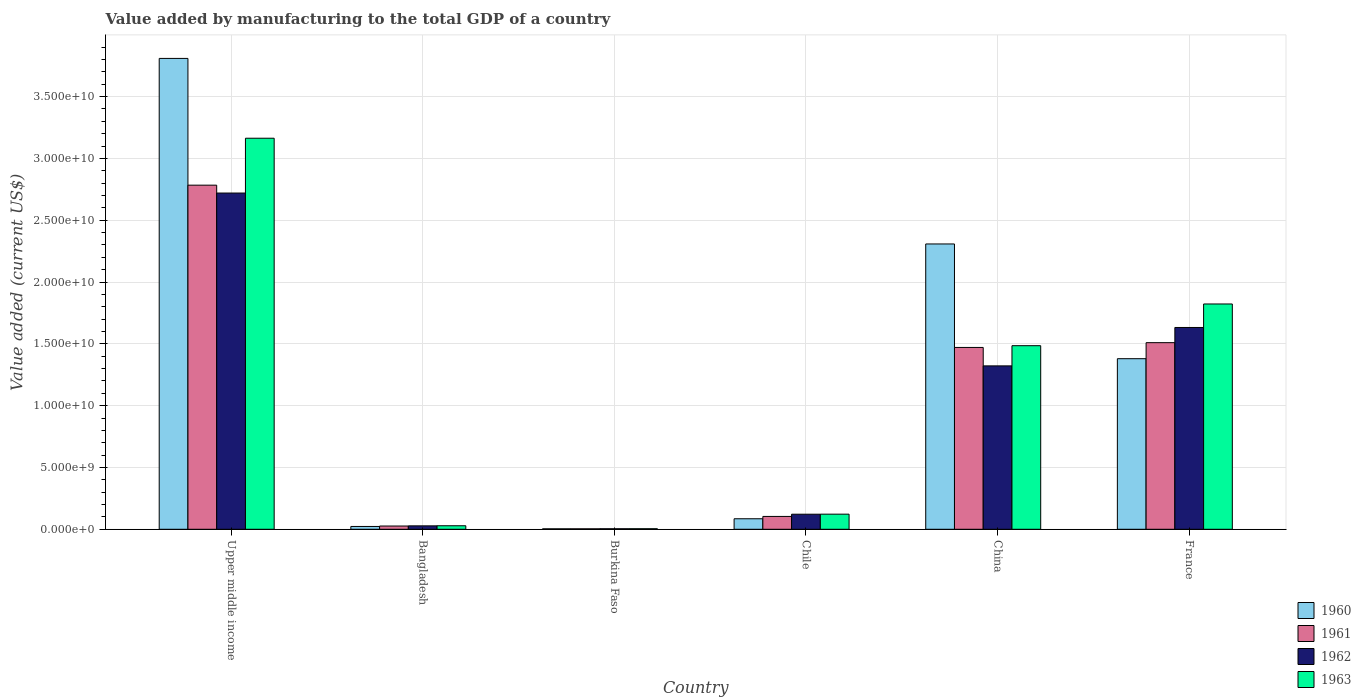How many different coloured bars are there?
Offer a terse response. 4. How many groups of bars are there?
Provide a succinct answer. 6. Are the number of bars per tick equal to the number of legend labels?
Ensure brevity in your answer.  Yes. What is the value added by manufacturing to the total GDP in 1960 in France?
Your answer should be compact. 1.38e+1. Across all countries, what is the maximum value added by manufacturing to the total GDP in 1960?
Your answer should be compact. 3.81e+1. Across all countries, what is the minimum value added by manufacturing to the total GDP in 1961?
Your answer should be compact. 3.72e+07. In which country was the value added by manufacturing to the total GDP in 1961 maximum?
Your response must be concise. Upper middle income. In which country was the value added by manufacturing to the total GDP in 1960 minimum?
Provide a succinct answer. Burkina Faso. What is the total value added by manufacturing to the total GDP in 1961 in the graph?
Provide a short and direct response. 5.90e+1. What is the difference between the value added by manufacturing to the total GDP in 1962 in Bangladesh and that in France?
Offer a terse response. -1.60e+1. What is the difference between the value added by manufacturing to the total GDP in 1960 in Chile and the value added by manufacturing to the total GDP in 1963 in Bangladesh?
Provide a succinct answer. 5.66e+08. What is the average value added by manufacturing to the total GDP in 1962 per country?
Ensure brevity in your answer.  9.71e+09. What is the difference between the value added by manufacturing to the total GDP of/in 1961 and value added by manufacturing to the total GDP of/in 1962 in Bangladesh?
Your answer should be very brief. -1.33e+07. What is the ratio of the value added by manufacturing to the total GDP in 1961 in Burkina Faso to that in Chile?
Keep it short and to the point. 0.04. Is the value added by manufacturing to the total GDP in 1963 in Chile less than that in France?
Keep it short and to the point. Yes. What is the difference between the highest and the second highest value added by manufacturing to the total GDP in 1961?
Provide a short and direct response. -1.31e+1. What is the difference between the highest and the lowest value added by manufacturing to the total GDP in 1960?
Offer a very short reply. 3.81e+1. Is it the case that in every country, the sum of the value added by manufacturing to the total GDP in 1962 and value added by manufacturing to the total GDP in 1961 is greater than the sum of value added by manufacturing to the total GDP in 1960 and value added by manufacturing to the total GDP in 1963?
Ensure brevity in your answer.  No. What does the 3rd bar from the left in Burkina Faso represents?
Your answer should be compact. 1962. Are all the bars in the graph horizontal?
Your answer should be compact. No. What is the difference between two consecutive major ticks on the Y-axis?
Keep it short and to the point. 5.00e+09. Does the graph contain grids?
Ensure brevity in your answer.  Yes. What is the title of the graph?
Offer a very short reply. Value added by manufacturing to the total GDP of a country. What is the label or title of the X-axis?
Keep it short and to the point. Country. What is the label or title of the Y-axis?
Your answer should be compact. Value added (current US$). What is the Value added (current US$) in 1960 in Upper middle income?
Keep it short and to the point. 3.81e+1. What is the Value added (current US$) in 1961 in Upper middle income?
Your answer should be compact. 2.78e+1. What is the Value added (current US$) of 1962 in Upper middle income?
Make the answer very short. 2.72e+1. What is the Value added (current US$) of 1963 in Upper middle income?
Offer a terse response. 3.16e+1. What is the Value added (current US$) in 1960 in Bangladesh?
Offer a very short reply. 2.27e+08. What is the Value added (current US$) in 1961 in Bangladesh?
Your answer should be very brief. 2.64e+08. What is the Value added (current US$) of 1962 in Bangladesh?
Your response must be concise. 2.77e+08. What is the Value added (current US$) of 1963 in Bangladesh?
Give a very brief answer. 2.85e+08. What is the Value added (current US$) of 1960 in Burkina Faso?
Keep it short and to the point. 3.72e+07. What is the Value added (current US$) of 1961 in Burkina Faso?
Give a very brief answer. 3.72e+07. What is the Value added (current US$) of 1962 in Burkina Faso?
Provide a succinct answer. 4.22e+07. What is the Value added (current US$) in 1963 in Burkina Faso?
Your answer should be compact. 4.39e+07. What is the Value added (current US$) of 1960 in Chile?
Give a very brief answer. 8.51e+08. What is the Value added (current US$) in 1961 in Chile?
Provide a succinct answer. 1.04e+09. What is the Value added (current US$) in 1962 in Chile?
Give a very brief answer. 1.22e+09. What is the Value added (current US$) in 1963 in Chile?
Provide a short and direct response. 1.22e+09. What is the Value added (current US$) of 1960 in China?
Provide a short and direct response. 2.31e+1. What is the Value added (current US$) of 1961 in China?
Provide a short and direct response. 1.47e+1. What is the Value added (current US$) of 1962 in China?
Ensure brevity in your answer.  1.32e+1. What is the Value added (current US$) in 1963 in China?
Your response must be concise. 1.49e+1. What is the Value added (current US$) in 1960 in France?
Keep it short and to the point. 1.38e+1. What is the Value added (current US$) of 1961 in France?
Provide a succinct answer. 1.51e+1. What is the Value added (current US$) of 1962 in France?
Ensure brevity in your answer.  1.63e+1. What is the Value added (current US$) of 1963 in France?
Offer a terse response. 1.82e+1. Across all countries, what is the maximum Value added (current US$) in 1960?
Keep it short and to the point. 3.81e+1. Across all countries, what is the maximum Value added (current US$) in 1961?
Ensure brevity in your answer.  2.78e+1. Across all countries, what is the maximum Value added (current US$) of 1962?
Offer a very short reply. 2.72e+1. Across all countries, what is the maximum Value added (current US$) of 1963?
Offer a terse response. 3.16e+1. Across all countries, what is the minimum Value added (current US$) of 1960?
Keep it short and to the point. 3.72e+07. Across all countries, what is the minimum Value added (current US$) of 1961?
Your answer should be very brief. 3.72e+07. Across all countries, what is the minimum Value added (current US$) of 1962?
Ensure brevity in your answer.  4.22e+07. Across all countries, what is the minimum Value added (current US$) in 1963?
Your answer should be compact. 4.39e+07. What is the total Value added (current US$) in 1960 in the graph?
Give a very brief answer. 7.61e+1. What is the total Value added (current US$) in 1961 in the graph?
Your answer should be very brief. 5.90e+1. What is the total Value added (current US$) of 1962 in the graph?
Give a very brief answer. 5.83e+1. What is the total Value added (current US$) of 1963 in the graph?
Provide a succinct answer. 6.63e+1. What is the difference between the Value added (current US$) of 1960 in Upper middle income and that in Bangladesh?
Offer a terse response. 3.79e+1. What is the difference between the Value added (current US$) of 1961 in Upper middle income and that in Bangladesh?
Offer a very short reply. 2.76e+1. What is the difference between the Value added (current US$) of 1962 in Upper middle income and that in Bangladesh?
Ensure brevity in your answer.  2.69e+1. What is the difference between the Value added (current US$) in 1963 in Upper middle income and that in Bangladesh?
Give a very brief answer. 3.13e+1. What is the difference between the Value added (current US$) in 1960 in Upper middle income and that in Burkina Faso?
Offer a very short reply. 3.81e+1. What is the difference between the Value added (current US$) of 1961 in Upper middle income and that in Burkina Faso?
Provide a short and direct response. 2.78e+1. What is the difference between the Value added (current US$) in 1962 in Upper middle income and that in Burkina Faso?
Ensure brevity in your answer.  2.72e+1. What is the difference between the Value added (current US$) in 1963 in Upper middle income and that in Burkina Faso?
Offer a terse response. 3.16e+1. What is the difference between the Value added (current US$) of 1960 in Upper middle income and that in Chile?
Your response must be concise. 3.72e+1. What is the difference between the Value added (current US$) in 1961 in Upper middle income and that in Chile?
Your answer should be very brief. 2.68e+1. What is the difference between the Value added (current US$) in 1962 in Upper middle income and that in Chile?
Provide a short and direct response. 2.60e+1. What is the difference between the Value added (current US$) in 1963 in Upper middle income and that in Chile?
Provide a short and direct response. 3.04e+1. What is the difference between the Value added (current US$) of 1960 in Upper middle income and that in China?
Offer a very short reply. 1.50e+1. What is the difference between the Value added (current US$) in 1961 in Upper middle income and that in China?
Make the answer very short. 1.31e+1. What is the difference between the Value added (current US$) of 1962 in Upper middle income and that in China?
Your response must be concise. 1.40e+1. What is the difference between the Value added (current US$) in 1963 in Upper middle income and that in China?
Your answer should be compact. 1.68e+1. What is the difference between the Value added (current US$) of 1960 in Upper middle income and that in France?
Provide a succinct answer. 2.43e+1. What is the difference between the Value added (current US$) in 1961 in Upper middle income and that in France?
Provide a succinct answer. 1.27e+1. What is the difference between the Value added (current US$) in 1962 in Upper middle income and that in France?
Give a very brief answer. 1.09e+1. What is the difference between the Value added (current US$) of 1963 in Upper middle income and that in France?
Give a very brief answer. 1.34e+1. What is the difference between the Value added (current US$) in 1960 in Bangladesh and that in Burkina Faso?
Your answer should be very brief. 1.90e+08. What is the difference between the Value added (current US$) in 1961 in Bangladesh and that in Burkina Faso?
Keep it short and to the point. 2.26e+08. What is the difference between the Value added (current US$) in 1962 in Bangladesh and that in Burkina Faso?
Ensure brevity in your answer.  2.35e+08. What is the difference between the Value added (current US$) of 1963 in Bangladesh and that in Burkina Faso?
Offer a terse response. 2.41e+08. What is the difference between the Value added (current US$) of 1960 in Bangladesh and that in Chile?
Offer a terse response. -6.24e+08. What is the difference between the Value added (current US$) in 1961 in Bangladesh and that in Chile?
Provide a short and direct response. -7.75e+08. What is the difference between the Value added (current US$) in 1962 in Bangladesh and that in Chile?
Provide a succinct answer. -9.41e+08. What is the difference between the Value added (current US$) of 1963 in Bangladesh and that in Chile?
Offer a very short reply. -9.38e+08. What is the difference between the Value added (current US$) of 1960 in Bangladesh and that in China?
Provide a succinct answer. -2.29e+1. What is the difference between the Value added (current US$) of 1961 in Bangladesh and that in China?
Your answer should be compact. -1.44e+1. What is the difference between the Value added (current US$) of 1962 in Bangladesh and that in China?
Offer a very short reply. -1.29e+1. What is the difference between the Value added (current US$) in 1963 in Bangladesh and that in China?
Keep it short and to the point. -1.46e+1. What is the difference between the Value added (current US$) of 1960 in Bangladesh and that in France?
Your answer should be very brief. -1.36e+1. What is the difference between the Value added (current US$) in 1961 in Bangladesh and that in France?
Offer a very short reply. -1.48e+1. What is the difference between the Value added (current US$) in 1962 in Bangladesh and that in France?
Ensure brevity in your answer.  -1.60e+1. What is the difference between the Value added (current US$) in 1963 in Bangladesh and that in France?
Offer a very short reply. -1.79e+1. What is the difference between the Value added (current US$) of 1960 in Burkina Faso and that in Chile?
Provide a short and direct response. -8.13e+08. What is the difference between the Value added (current US$) in 1961 in Burkina Faso and that in Chile?
Your response must be concise. -1.00e+09. What is the difference between the Value added (current US$) of 1962 in Burkina Faso and that in Chile?
Ensure brevity in your answer.  -1.18e+09. What is the difference between the Value added (current US$) of 1963 in Burkina Faso and that in Chile?
Your answer should be very brief. -1.18e+09. What is the difference between the Value added (current US$) in 1960 in Burkina Faso and that in China?
Your response must be concise. -2.30e+1. What is the difference between the Value added (current US$) of 1961 in Burkina Faso and that in China?
Provide a short and direct response. -1.47e+1. What is the difference between the Value added (current US$) of 1962 in Burkina Faso and that in China?
Keep it short and to the point. -1.32e+1. What is the difference between the Value added (current US$) of 1963 in Burkina Faso and that in China?
Your response must be concise. -1.48e+1. What is the difference between the Value added (current US$) in 1960 in Burkina Faso and that in France?
Offer a very short reply. -1.38e+1. What is the difference between the Value added (current US$) of 1961 in Burkina Faso and that in France?
Your answer should be compact. -1.51e+1. What is the difference between the Value added (current US$) in 1962 in Burkina Faso and that in France?
Provide a short and direct response. -1.63e+1. What is the difference between the Value added (current US$) of 1963 in Burkina Faso and that in France?
Your answer should be compact. -1.82e+1. What is the difference between the Value added (current US$) of 1960 in Chile and that in China?
Provide a succinct answer. -2.22e+1. What is the difference between the Value added (current US$) in 1961 in Chile and that in China?
Offer a terse response. -1.37e+1. What is the difference between the Value added (current US$) in 1962 in Chile and that in China?
Offer a very short reply. -1.20e+1. What is the difference between the Value added (current US$) in 1963 in Chile and that in China?
Make the answer very short. -1.36e+1. What is the difference between the Value added (current US$) in 1960 in Chile and that in France?
Give a very brief answer. -1.29e+1. What is the difference between the Value added (current US$) of 1961 in Chile and that in France?
Ensure brevity in your answer.  -1.41e+1. What is the difference between the Value added (current US$) of 1962 in Chile and that in France?
Keep it short and to the point. -1.51e+1. What is the difference between the Value added (current US$) of 1963 in Chile and that in France?
Provide a succinct answer. -1.70e+1. What is the difference between the Value added (current US$) of 1960 in China and that in France?
Give a very brief answer. 9.28e+09. What is the difference between the Value added (current US$) in 1961 in China and that in France?
Offer a very short reply. -3.87e+08. What is the difference between the Value added (current US$) in 1962 in China and that in France?
Your response must be concise. -3.11e+09. What is the difference between the Value added (current US$) of 1963 in China and that in France?
Keep it short and to the point. -3.37e+09. What is the difference between the Value added (current US$) in 1960 in Upper middle income and the Value added (current US$) in 1961 in Bangladesh?
Offer a terse response. 3.78e+1. What is the difference between the Value added (current US$) of 1960 in Upper middle income and the Value added (current US$) of 1962 in Bangladesh?
Your answer should be very brief. 3.78e+1. What is the difference between the Value added (current US$) of 1960 in Upper middle income and the Value added (current US$) of 1963 in Bangladesh?
Your answer should be compact. 3.78e+1. What is the difference between the Value added (current US$) of 1961 in Upper middle income and the Value added (current US$) of 1962 in Bangladesh?
Your response must be concise. 2.76e+1. What is the difference between the Value added (current US$) of 1961 in Upper middle income and the Value added (current US$) of 1963 in Bangladesh?
Your answer should be very brief. 2.76e+1. What is the difference between the Value added (current US$) in 1962 in Upper middle income and the Value added (current US$) in 1963 in Bangladesh?
Provide a succinct answer. 2.69e+1. What is the difference between the Value added (current US$) in 1960 in Upper middle income and the Value added (current US$) in 1961 in Burkina Faso?
Offer a very short reply. 3.81e+1. What is the difference between the Value added (current US$) in 1960 in Upper middle income and the Value added (current US$) in 1962 in Burkina Faso?
Ensure brevity in your answer.  3.80e+1. What is the difference between the Value added (current US$) of 1960 in Upper middle income and the Value added (current US$) of 1963 in Burkina Faso?
Keep it short and to the point. 3.80e+1. What is the difference between the Value added (current US$) in 1961 in Upper middle income and the Value added (current US$) in 1962 in Burkina Faso?
Offer a terse response. 2.78e+1. What is the difference between the Value added (current US$) in 1961 in Upper middle income and the Value added (current US$) in 1963 in Burkina Faso?
Give a very brief answer. 2.78e+1. What is the difference between the Value added (current US$) in 1962 in Upper middle income and the Value added (current US$) in 1963 in Burkina Faso?
Your response must be concise. 2.72e+1. What is the difference between the Value added (current US$) of 1960 in Upper middle income and the Value added (current US$) of 1961 in Chile?
Give a very brief answer. 3.71e+1. What is the difference between the Value added (current US$) in 1960 in Upper middle income and the Value added (current US$) in 1962 in Chile?
Provide a succinct answer. 3.69e+1. What is the difference between the Value added (current US$) of 1960 in Upper middle income and the Value added (current US$) of 1963 in Chile?
Make the answer very short. 3.69e+1. What is the difference between the Value added (current US$) of 1961 in Upper middle income and the Value added (current US$) of 1962 in Chile?
Provide a succinct answer. 2.66e+1. What is the difference between the Value added (current US$) of 1961 in Upper middle income and the Value added (current US$) of 1963 in Chile?
Offer a terse response. 2.66e+1. What is the difference between the Value added (current US$) of 1962 in Upper middle income and the Value added (current US$) of 1963 in Chile?
Ensure brevity in your answer.  2.60e+1. What is the difference between the Value added (current US$) of 1960 in Upper middle income and the Value added (current US$) of 1961 in China?
Offer a terse response. 2.34e+1. What is the difference between the Value added (current US$) of 1960 in Upper middle income and the Value added (current US$) of 1962 in China?
Provide a succinct answer. 2.49e+1. What is the difference between the Value added (current US$) in 1960 in Upper middle income and the Value added (current US$) in 1963 in China?
Provide a short and direct response. 2.32e+1. What is the difference between the Value added (current US$) in 1961 in Upper middle income and the Value added (current US$) in 1962 in China?
Make the answer very short. 1.46e+1. What is the difference between the Value added (current US$) in 1961 in Upper middle income and the Value added (current US$) in 1963 in China?
Your answer should be compact. 1.30e+1. What is the difference between the Value added (current US$) in 1962 in Upper middle income and the Value added (current US$) in 1963 in China?
Give a very brief answer. 1.23e+1. What is the difference between the Value added (current US$) of 1960 in Upper middle income and the Value added (current US$) of 1961 in France?
Your answer should be very brief. 2.30e+1. What is the difference between the Value added (current US$) in 1960 in Upper middle income and the Value added (current US$) in 1962 in France?
Give a very brief answer. 2.18e+1. What is the difference between the Value added (current US$) in 1960 in Upper middle income and the Value added (current US$) in 1963 in France?
Your response must be concise. 1.99e+1. What is the difference between the Value added (current US$) in 1961 in Upper middle income and the Value added (current US$) in 1962 in France?
Your answer should be very brief. 1.15e+1. What is the difference between the Value added (current US$) of 1961 in Upper middle income and the Value added (current US$) of 1963 in France?
Ensure brevity in your answer.  9.61e+09. What is the difference between the Value added (current US$) in 1962 in Upper middle income and the Value added (current US$) in 1963 in France?
Make the answer very short. 8.97e+09. What is the difference between the Value added (current US$) in 1960 in Bangladesh and the Value added (current US$) in 1961 in Burkina Faso?
Your answer should be compact. 1.90e+08. What is the difference between the Value added (current US$) in 1960 in Bangladesh and the Value added (current US$) in 1962 in Burkina Faso?
Keep it short and to the point. 1.85e+08. What is the difference between the Value added (current US$) in 1960 in Bangladesh and the Value added (current US$) in 1963 in Burkina Faso?
Make the answer very short. 1.83e+08. What is the difference between the Value added (current US$) of 1961 in Bangladesh and the Value added (current US$) of 1962 in Burkina Faso?
Give a very brief answer. 2.21e+08. What is the difference between the Value added (current US$) of 1961 in Bangladesh and the Value added (current US$) of 1963 in Burkina Faso?
Provide a short and direct response. 2.20e+08. What is the difference between the Value added (current US$) of 1962 in Bangladesh and the Value added (current US$) of 1963 in Burkina Faso?
Keep it short and to the point. 2.33e+08. What is the difference between the Value added (current US$) of 1960 in Bangladesh and the Value added (current US$) of 1961 in Chile?
Ensure brevity in your answer.  -8.12e+08. What is the difference between the Value added (current US$) in 1960 in Bangladesh and the Value added (current US$) in 1962 in Chile?
Your response must be concise. -9.91e+08. What is the difference between the Value added (current US$) of 1960 in Bangladesh and the Value added (current US$) of 1963 in Chile?
Make the answer very short. -9.96e+08. What is the difference between the Value added (current US$) of 1961 in Bangladesh and the Value added (current US$) of 1962 in Chile?
Provide a short and direct response. -9.55e+08. What is the difference between the Value added (current US$) in 1961 in Bangladesh and the Value added (current US$) in 1963 in Chile?
Keep it short and to the point. -9.59e+08. What is the difference between the Value added (current US$) in 1962 in Bangladesh and the Value added (current US$) in 1963 in Chile?
Your response must be concise. -9.46e+08. What is the difference between the Value added (current US$) of 1960 in Bangladesh and the Value added (current US$) of 1961 in China?
Give a very brief answer. -1.45e+1. What is the difference between the Value added (current US$) in 1960 in Bangladesh and the Value added (current US$) in 1962 in China?
Provide a short and direct response. -1.30e+1. What is the difference between the Value added (current US$) in 1960 in Bangladesh and the Value added (current US$) in 1963 in China?
Your answer should be compact. -1.46e+1. What is the difference between the Value added (current US$) in 1961 in Bangladesh and the Value added (current US$) in 1962 in China?
Keep it short and to the point. -1.30e+1. What is the difference between the Value added (current US$) in 1961 in Bangladesh and the Value added (current US$) in 1963 in China?
Your answer should be compact. -1.46e+1. What is the difference between the Value added (current US$) of 1962 in Bangladesh and the Value added (current US$) of 1963 in China?
Offer a very short reply. -1.46e+1. What is the difference between the Value added (current US$) of 1960 in Bangladesh and the Value added (current US$) of 1961 in France?
Offer a very short reply. -1.49e+1. What is the difference between the Value added (current US$) in 1960 in Bangladesh and the Value added (current US$) in 1962 in France?
Your answer should be very brief. -1.61e+1. What is the difference between the Value added (current US$) of 1960 in Bangladesh and the Value added (current US$) of 1963 in France?
Ensure brevity in your answer.  -1.80e+1. What is the difference between the Value added (current US$) of 1961 in Bangladesh and the Value added (current US$) of 1962 in France?
Your answer should be very brief. -1.61e+1. What is the difference between the Value added (current US$) of 1961 in Bangladesh and the Value added (current US$) of 1963 in France?
Ensure brevity in your answer.  -1.80e+1. What is the difference between the Value added (current US$) in 1962 in Bangladesh and the Value added (current US$) in 1963 in France?
Ensure brevity in your answer.  -1.79e+1. What is the difference between the Value added (current US$) of 1960 in Burkina Faso and the Value added (current US$) of 1961 in Chile?
Give a very brief answer. -1.00e+09. What is the difference between the Value added (current US$) of 1960 in Burkina Faso and the Value added (current US$) of 1962 in Chile?
Provide a short and direct response. -1.18e+09. What is the difference between the Value added (current US$) of 1960 in Burkina Faso and the Value added (current US$) of 1963 in Chile?
Offer a terse response. -1.19e+09. What is the difference between the Value added (current US$) of 1961 in Burkina Faso and the Value added (current US$) of 1962 in Chile?
Offer a very short reply. -1.18e+09. What is the difference between the Value added (current US$) of 1961 in Burkina Faso and the Value added (current US$) of 1963 in Chile?
Ensure brevity in your answer.  -1.19e+09. What is the difference between the Value added (current US$) of 1962 in Burkina Faso and the Value added (current US$) of 1963 in Chile?
Provide a succinct answer. -1.18e+09. What is the difference between the Value added (current US$) in 1960 in Burkina Faso and the Value added (current US$) in 1961 in China?
Give a very brief answer. -1.47e+1. What is the difference between the Value added (current US$) of 1960 in Burkina Faso and the Value added (current US$) of 1962 in China?
Give a very brief answer. -1.32e+1. What is the difference between the Value added (current US$) in 1960 in Burkina Faso and the Value added (current US$) in 1963 in China?
Offer a very short reply. -1.48e+1. What is the difference between the Value added (current US$) in 1961 in Burkina Faso and the Value added (current US$) in 1962 in China?
Make the answer very short. -1.32e+1. What is the difference between the Value added (current US$) in 1961 in Burkina Faso and the Value added (current US$) in 1963 in China?
Your response must be concise. -1.48e+1. What is the difference between the Value added (current US$) of 1962 in Burkina Faso and the Value added (current US$) of 1963 in China?
Keep it short and to the point. -1.48e+1. What is the difference between the Value added (current US$) in 1960 in Burkina Faso and the Value added (current US$) in 1961 in France?
Offer a very short reply. -1.51e+1. What is the difference between the Value added (current US$) in 1960 in Burkina Faso and the Value added (current US$) in 1962 in France?
Your response must be concise. -1.63e+1. What is the difference between the Value added (current US$) in 1960 in Burkina Faso and the Value added (current US$) in 1963 in France?
Make the answer very short. -1.82e+1. What is the difference between the Value added (current US$) of 1961 in Burkina Faso and the Value added (current US$) of 1962 in France?
Keep it short and to the point. -1.63e+1. What is the difference between the Value added (current US$) of 1961 in Burkina Faso and the Value added (current US$) of 1963 in France?
Make the answer very short. -1.82e+1. What is the difference between the Value added (current US$) of 1962 in Burkina Faso and the Value added (current US$) of 1963 in France?
Make the answer very short. -1.82e+1. What is the difference between the Value added (current US$) in 1960 in Chile and the Value added (current US$) in 1961 in China?
Provide a succinct answer. -1.39e+1. What is the difference between the Value added (current US$) in 1960 in Chile and the Value added (current US$) in 1962 in China?
Keep it short and to the point. -1.24e+1. What is the difference between the Value added (current US$) in 1960 in Chile and the Value added (current US$) in 1963 in China?
Keep it short and to the point. -1.40e+1. What is the difference between the Value added (current US$) of 1961 in Chile and the Value added (current US$) of 1962 in China?
Your answer should be very brief. -1.22e+1. What is the difference between the Value added (current US$) of 1961 in Chile and the Value added (current US$) of 1963 in China?
Your response must be concise. -1.38e+1. What is the difference between the Value added (current US$) of 1962 in Chile and the Value added (current US$) of 1963 in China?
Your response must be concise. -1.36e+1. What is the difference between the Value added (current US$) of 1960 in Chile and the Value added (current US$) of 1961 in France?
Make the answer very short. -1.42e+1. What is the difference between the Value added (current US$) of 1960 in Chile and the Value added (current US$) of 1962 in France?
Provide a succinct answer. -1.55e+1. What is the difference between the Value added (current US$) of 1960 in Chile and the Value added (current US$) of 1963 in France?
Keep it short and to the point. -1.74e+1. What is the difference between the Value added (current US$) of 1961 in Chile and the Value added (current US$) of 1962 in France?
Your answer should be compact. -1.53e+1. What is the difference between the Value added (current US$) in 1961 in Chile and the Value added (current US$) in 1963 in France?
Your answer should be compact. -1.72e+1. What is the difference between the Value added (current US$) of 1962 in Chile and the Value added (current US$) of 1963 in France?
Your response must be concise. -1.70e+1. What is the difference between the Value added (current US$) in 1960 in China and the Value added (current US$) in 1961 in France?
Provide a succinct answer. 7.98e+09. What is the difference between the Value added (current US$) of 1960 in China and the Value added (current US$) of 1962 in France?
Your answer should be very brief. 6.76e+09. What is the difference between the Value added (current US$) in 1960 in China and the Value added (current US$) in 1963 in France?
Offer a terse response. 4.86e+09. What is the difference between the Value added (current US$) of 1961 in China and the Value added (current US$) of 1962 in France?
Provide a short and direct response. -1.61e+09. What is the difference between the Value added (current US$) in 1961 in China and the Value added (current US$) in 1963 in France?
Your answer should be compact. -3.52e+09. What is the difference between the Value added (current US$) of 1962 in China and the Value added (current US$) of 1963 in France?
Provide a short and direct response. -5.01e+09. What is the average Value added (current US$) of 1960 per country?
Your response must be concise. 1.27e+1. What is the average Value added (current US$) of 1961 per country?
Give a very brief answer. 9.83e+09. What is the average Value added (current US$) of 1962 per country?
Give a very brief answer. 9.71e+09. What is the average Value added (current US$) of 1963 per country?
Your response must be concise. 1.10e+1. What is the difference between the Value added (current US$) of 1960 and Value added (current US$) of 1961 in Upper middle income?
Your response must be concise. 1.03e+1. What is the difference between the Value added (current US$) in 1960 and Value added (current US$) in 1962 in Upper middle income?
Offer a terse response. 1.09e+1. What is the difference between the Value added (current US$) in 1960 and Value added (current US$) in 1963 in Upper middle income?
Your response must be concise. 6.46e+09. What is the difference between the Value added (current US$) of 1961 and Value added (current US$) of 1962 in Upper middle income?
Make the answer very short. 6.38e+08. What is the difference between the Value added (current US$) of 1961 and Value added (current US$) of 1963 in Upper middle income?
Your answer should be compact. -3.80e+09. What is the difference between the Value added (current US$) of 1962 and Value added (current US$) of 1963 in Upper middle income?
Your answer should be compact. -4.43e+09. What is the difference between the Value added (current US$) of 1960 and Value added (current US$) of 1961 in Bangladesh?
Your answer should be very brief. -3.66e+07. What is the difference between the Value added (current US$) in 1960 and Value added (current US$) in 1962 in Bangladesh?
Make the answer very short. -4.99e+07. What is the difference between the Value added (current US$) of 1960 and Value added (current US$) of 1963 in Bangladesh?
Your answer should be compact. -5.81e+07. What is the difference between the Value added (current US$) of 1961 and Value added (current US$) of 1962 in Bangladesh?
Offer a terse response. -1.33e+07. What is the difference between the Value added (current US$) in 1961 and Value added (current US$) in 1963 in Bangladesh?
Offer a very short reply. -2.15e+07. What is the difference between the Value added (current US$) of 1962 and Value added (current US$) of 1963 in Bangladesh?
Provide a succinct answer. -8.22e+06. What is the difference between the Value added (current US$) in 1960 and Value added (current US$) in 1961 in Burkina Faso?
Offer a very short reply. 9866.11. What is the difference between the Value added (current US$) in 1960 and Value added (current US$) in 1962 in Burkina Faso?
Provide a short and direct response. -5.00e+06. What is the difference between the Value added (current US$) in 1960 and Value added (current US$) in 1963 in Burkina Faso?
Provide a succinct answer. -6.65e+06. What is the difference between the Value added (current US$) of 1961 and Value added (current US$) of 1962 in Burkina Faso?
Make the answer very short. -5.01e+06. What is the difference between the Value added (current US$) in 1961 and Value added (current US$) in 1963 in Burkina Faso?
Offer a terse response. -6.66e+06. What is the difference between the Value added (current US$) of 1962 and Value added (current US$) of 1963 in Burkina Faso?
Offer a very short reply. -1.65e+06. What is the difference between the Value added (current US$) in 1960 and Value added (current US$) in 1961 in Chile?
Keep it short and to the point. -1.88e+08. What is the difference between the Value added (current US$) in 1960 and Value added (current US$) in 1962 in Chile?
Provide a succinct answer. -3.68e+08. What is the difference between the Value added (current US$) in 1960 and Value added (current US$) in 1963 in Chile?
Give a very brief answer. -3.72e+08. What is the difference between the Value added (current US$) of 1961 and Value added (current US$) of 1962 in Chile?
Offer a very short reply. -1.80e+08. What is the difference between the Value added (current US$) of 1961 and Value added (current US$) of 1963 in Chile?
Keep it short and to the point. -1.84e+08. What is the difference between the Value added (current US$) in 1962 and Value added (current US$) in 1963 in Chile?
Keep it short and to the point. -4.28e+06. What is the difference between the Value added (current US$) in 1960 and Value added (current US$) in 1961 in China?
Your answer should be very brief. 8.37e+09. What is the difference between the Value added (current US$) in 1960 and Value added (current US$) in 1962 in China?
Your answer should be very brief. 9.86e+09. What is the difference between the Value added (current US$) of 1960 and Value added (current US$) of 1963 in China?
Your response must be concise. 8.23e+09. What is the difference between the Value added (current US$) in 1961 and Value added (current US$) in 1962 in China?
Make the answer very short. 1.49e+09. What is the difference between the Value added (current US$) of 1961 and Value added (current US$) of 1963 in China?
Make the answer very short. -1.42e+08. What is the difference between the Value added (current US$) of 1962 and Value added (current US$) of 1963 in China?
Offer a very short reply. -1.63e+09. What is the difference between the Value added (current US$) of 1960 and Value added (current US$) of 1961 in France?
Offer a terse response. -1.30e+09. What is the difference between the Value added (current US$) of 1960 and Value added (current US$) of 1962 in France?
Provide a succinct answer. -2.52e+09. What is the difference between the Value added (current US$) in 1960 and Value added (current US$) in 1963 in France?
Ensure brevity in your answer.  -4.43e+09. What is the difference between the Value added (current US$) of 1961 and Value added (current US$) of 1962 in France?
Offer a very short reply. -1.23e+09. What is the difference between the Value added (current US$) of 1961 and Value added (current US$) of 1963 in France?
Your answer should be very brief. -3.13e+09. What is the difference between the Value added (current US$) of 1962 and Value added (current US$) of 1963 in France?
Offer a terse response. -1.90e+09. What is the ratio of the Value added (current US$) of 1960 in Upper middle income to that in Bangladesh?
Provide a short and direct response. 167.8. What is the ratio of the Value added (current US$) in 1961 in Upper middle income to that in Bangladesh?
Give a very brief answer. 105.62. What is the ratio of the Value added (current US$) in 1962 in Upper middle income to that in Bangladesh?
Give a very brief answer. 98.24. What is the ratio of the Value added (current US$) of 1963 in Upper middle income to that in Bangladesh?
Ensure brevity in your answer.  110.96. What is the ratio of the Value added (current US$) in 1960 in Upper middle income to that in Burkina Faso?
Ensure brevity in your answer.  1023.17. What is the ratio of the Value added (current US$) in 1961 in Upper middle income to that in Burkina Faso?
Give a very brief answer. 747.95. What is the ratio of the Value added (current US$) of 1962 in Upper middle income to that in Burkina Faso?
Provide a succinct answer. 644.09. What is the ratio of the Value added (current US$) in 1963 in Upper middle income to that in Burkina Faso?
Provide a succinct answer. 720.87. What is the ratio of the Value added (current US$) of 1960 in Upper middle income to that in Chile?
Offer a terse response. 44.77. What is the ratio of the Value added (current US$) in 1961 in Upper middle income to that in Chile?
Offer a very short reply. 26.8. What is the ratio of the Value added (current US$) of 1962 in Upper middle income to that in Chile?
Your response must be concise. 22.32. What is the ratio of the Value added (current US$) of 1963 in Upper middle income to that in Chile?
Make the answer very short. 25.87. What is the ratio of the Value added (current US$) in 1960 in Upper middle income to that in China?
Ensure brevity in your answer.  1.65. What is the ratio of the Value added (current US$) of 1961 in Upper middle income to that in China?
Provide a succinct answer. 1.89. What is the ratio of the Value added (current US$) in 1962 in Upper middle income to that in China?
Make the answer very short. 2.06. What is the ratio of the Value added (current US$) in 1963 in Upper middle income to that in China?
Your answer should be compact. 2.13. What is the ratio of the Value added (current US$) of 1960 in Upper middle income to that in France?
Provide a succinct answer. 2.76. What is the ratio of the Value added (current US$) in 1961 in Upper middle income to that in France?
Your answer should be very brief. 1.84. What is the ratio of the Value added (current US$) in 1962 in Upper middle income to that in France?
Make the answer very short. 1.67. What is the ratio of the Value added (current US$) of 1963 in Upper middle income to that in France?
Provide a succinct answer. 1.74. What is the ratio of the Value added (current US$) in 1960 in Bangladesh to that in Burkina Faso?
Give a very brief answer. 6.1. What is the ratio of the Value added (current US$) in 1961 in Bangladesh to that in Burkina Faso?
Keep it short and to the point. 7.08. What is the ratio of the Value added (current US$) of 1962 in Bangladesh to that in Burkina Faso?
Ensure brevity in your answer.  6.56. What is the ratio of the Value added (current US$) of 1963 in Bangladesh to that in Burkina Faso?
Ensure brevity in your answer.  6.5. What is the ratio of the Value added (current US$) of 1960 in Bangladesh to that in Chile?
Your answer should be compact. 0.27. What is the ratio of the Value added (current US$) of 1961 in Bangladesh to that in Chile?
Offer a terse response. 0.25. What is the ratio of the Value added (current US$) of 1962 in Bangladesh to that in Chile?
Your answer should be very brief. 0.23. What is the ratio of the Value added (current US$) in 1963 in Bangladesh to that in Chile?
Ensure brevity in your answer.  0.23. What is the ratio of the Value added (current US$) of 1960 in Bangladesh to that in China?
Provide a short and direct response. 0.01. What is the ratio of the Value added (current US$) of 1961 in Bangladesh to that in China?
Offer a very short reply. 0.02. What is the ratio of the Value added (current US$) in 1962 in Bangladesh to that in China?
Offer a very short reply. 0.02. What is the ratio of the Value added (current US$) of 1963 in Bangladesh to that in China?
Provide a succinct answer. 0.02. What is the ratio of the Value added (current US$) of 1960 in Bangladesh to that in France?
Offer a terse response. 0.02. What is the ratio of the Value added (current US$) in 1961 in Bangladesh to that in France?
Give a very brief answer. 0.02. What is the ratio of the Value added (current US$) of 1962 in Bangladesh to that in France?
Provide a short and direct response. 0.02. What is the ratio of the Value added (current US$) in 1963 in Bangladesh to that in France?
Your response must be concise. 0.02. What is the ratio of the Value added (current US$) of 1960 in Burkina Faso to that in Chile?
Your answer should be very brief. 0.04. What is the ratio of the Value added (current US$) of 1961 in Burkina Faso to that in Chile?
Your response must be concise. 0.04. What is the ratio of the Value added (current US$) of 1962 in Burkina Faso to that in Chile?
Give a very brief answer. 0.03. What is the ratio of the Value added (current US$) of 1963 in Burkina Faso to that in Chile?
Keep it short and to the point. 0.04. What is the ratio of the Value added (current US$) of 1960 in Burkina Faso to that in China?
Keep it short and to the point. 0. What is the ratio of the Value added (current US$) in 1961 in Burkina Faso to that in China?
Ensure brevity in your answer.  0. What is the ratio of the Value added (current US$) in 1962 in Burkina Faso to that in China?
Ensure brevity in your answer.  0. What is the ratio of the Value added (current US$) in 1963 in Burkina Faso to that in China?
Ensure brevity in your answer.  0. What is the ratio of the Value added (current US$) in 1960 in Burkina Faso to that in France?
Keep it short and to the point. 0. What is the ratio of the Value added (current US$) of 1961 in Burkina Faso to that in France?
Make the answer very short. 0. What is the ratio of the Value added (current US$) in 1962 in Burkina Faso to that in France?
Provide a short and direct response. 0. What is the ratio of the Value added (current US$) of 1963 in Burkina Faso to that in France?
Offer a very short reply. 0. What is the ratio of the Value added (current US$) in 1960 in Chile to that in China?
Your answer should be compact. 0.04. What is the ratio of the Value added (current US$) of 1961 in Chile to that in China?
Your response must be concise. 0.07. What is the ratio of the Value added (current US$) in 1962 in Chile to that in China?
Give a very brief answer. 0.09. What is the ratio of the Value added (current US$) in 1963 in Chile to that in China?
Ensure brevity in your answer.  0.08. What is the ratio of the Value added (current US$) in 1960 in Chile to that in France?
Ensure brevity in your answer.  0.06. What is the ratio of the Value added (current US$) in 1961 in Chile to that in France?
Provide a succinct answer. 0.07. What is the ratio of the Value added (current US$) in 1962 in Chile to that in France?
Provide a succinct answer. 0.07. What is the ratio of the Value added (current US$) in 1963 in Chile to that in France?
Make the answer very short. 0.07. What is the ratio of the Value added (current US$) in 1960 in China to that in France?
Keep it short and to the point. 1.67. What is the ratio of the Value added (current US$) of 1961 in China to that in France?
Ensure brevity in your answer.  0.97. What is the ratio of the Value added (current US$) in 1962 in China to that in France?
Offer a terse response. 0.81. What is the ratio of the Value added (current US$) in 1963 in China to that in France?
Offer a very short reply. 0.81. What is the difference between the highest and the second highest Value added (current US$) of 1960?
Keep it short and to the point. 1.50e+1. What is the difference between the highest and the second highest Value added (current US$) of 1961?
Keep it short and to the point. 1.27e+1. What is the difference between the highest and the second highest Value added (current US$) in 1962?
Your response must be concise. 1.09e+1. What is the difference between the highest and the second highest Value added (current US$) in 1963?
Your answer should be very brief. 1.34e+1. What is the difference between the highest and the lowest Value added (current US$) in 1960?
Make the answer very short. 3.81e+1. What is the difference between the highest and the lowest Value added (current US$) in 1961?
Provide a short and direct response. 2.78e+1. What is the difference between the highest and the lowest Value added (current US$) in 1962?
Offer a very short reply. 2.72e+1. What is the difference between the highest and the lowest Value added (current US$) in 1963?
Your answer should be compact. 3.16e+1. 